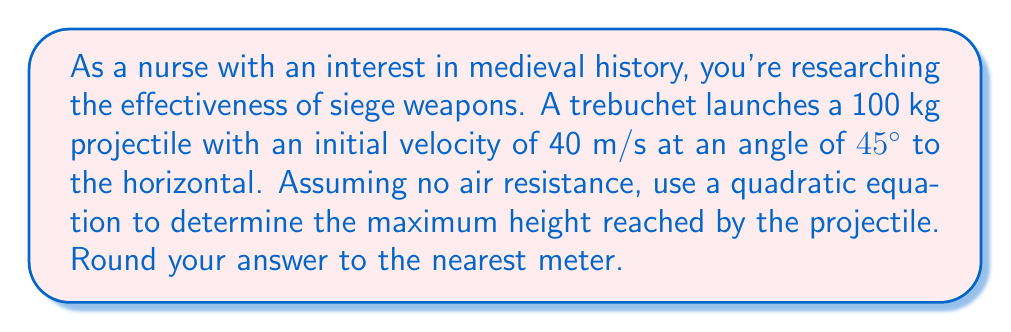Show me your answer to this math problem. To solve this problem, we'll use the quadratic equation that describes the vertical motion of a projectile:

$$y = -\frac{1}{2}gt^2 + v_0\sin(\theta)t + y_0$$

Where:
$y$ is the vertical position
$g$ is the acceleration due to gravity (9.8 m/s²)
$t$ is time
$v_0$ is the initial velocity
$\theta$ is the launch angle
$y_0$ is the initial height (assumed to be 0 in this case)

Given:
$v_0 = 40$ m/s
$\theta = 45°$
$y_0 = 0$ m

Step 1: Calculate the vertical component of the initial velocity:
$v_0\sin(\theta) = 40 \sin(45°) = 40 \cdot \frac{\sqrt{2}}{2} \approx 28.28$ m/s

Step 2: Our equation becomes:
$$y = -4.9t^2 + 28.28t$$

Step 3: To find the maximum height, we need to find when the vertical velocity is zero. We can do this by taking the derivative of y with respect to t and setting it to zero:

$$\frac{dy}{dt} = -9.8t + 28.28 = 0$$

Step 4: Solve for t:
$$t = \frac{28.28}{9.8} \approx 2.88\text{ seconds}$$

Step 5: Substitute this time back into our original equation to find the maximum height:

$$y = -4.9(2.88)^2 + 28.28(2.88) \approx 40.82\text{ meters}$$

Step 6: Round to the nearest meter:
Maximum height ≈ 41 meters
Answer: 41 meters 